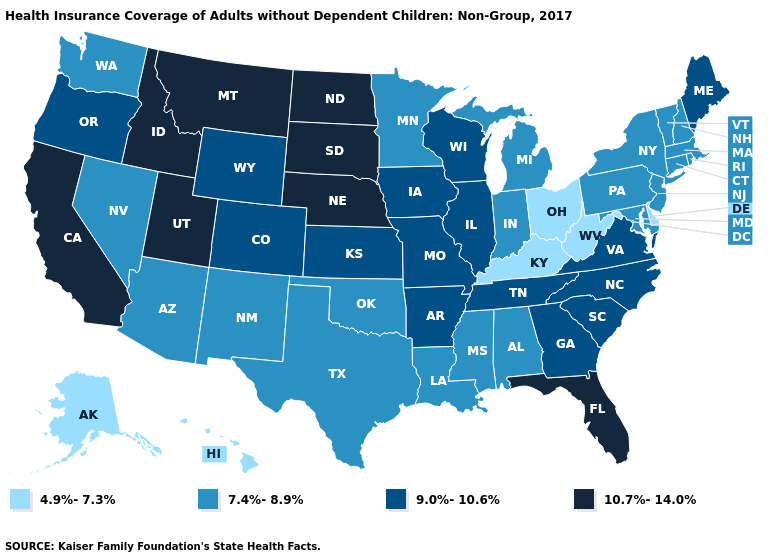Which states have the lowest value in the South?
Give a very brief answer. Delaware, Kentucky, West Virginia. What is the value of Kansas?
Concise answer only. 9.0%-10.6%. Name the states that have a value in the range 9.0%-10.6%?
Concise answer only. Arkansas, Colorado, Georgia, Illinois, Iowa, Kansas, Maine, Missouri, North Carolina, Oregon, South Carolina, Tennessee, Virginia, Wisconsin, Wyoming. What is the value of Indiana?
Give a very brief answer. 7.4%-8.9%. What is the highest value in states that border West Virginia?
Write a very short answer. 9.0%-10.6%. Is the legend a continuous bar?
Concise answer only. No. Among the states that border Florida , which have the lowest value?
Write a very short answer. Alabama. Name the states that have a value in the range 7.4%-8.9%?
Concise answer only. Alabama, Arizona, Connecticut, Indiana, Louisiana, Maryland, Massachusetts, Michigan, Minnesota, Mississippi, Nevada, New Hampshire, New Jersey, New Mexico, New York, Oklahoma, Pennsylvania, Rhode Island, Texas, Vermont, Washington. What is the value of North Carolina?
Short answer required. 9.0%-10.6%. Is the legend a continuous bar?
Answer briefly. No. What is the lowest value in the South?
Answer briefly. 4.9%-7.3%. Does New Jersey have the lowest value in the Northeast?
Be succinct. Yes. Which states have the lowest value in the USA?
Write a very short answer. Alaska, Delaware, Hawaii, Kentucky, Ohio, West Virginia. Name the states that have a value in the range 4.9%-7.3%?
Write a very short answer. Alaska, Delaware, Hawaii, Kentucky, Ohio, West Virginia. Which states have the lowest value in the USA?
Short answer required. Alaska, Delaware, Hawaii, Kentucky, Ohio, West Virginia. 